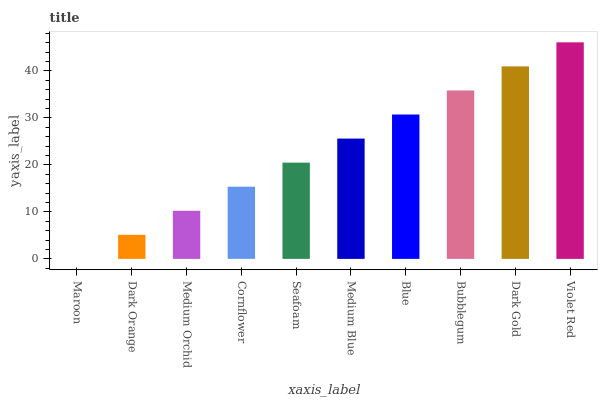Is Dark Orange the minimum?
Answer yes or no. No. Is Dark Orange the maximum?
Answer yes or no. No. Is Dark Orange greater than Maroon?
Answer yes or no. Yes. Is Maroon less than Dark Orange?
Answer yes or no. Yes. Is Maroon greater than Dark Orange?
Answer yes or no. No. Is Dark Orange less than Maroon?
Answer yes or no. No. Is Medium Blue the high median?
Answer yes or no. Yes. Is Seafoam the low median?
Answer yes or no. Yes. Is Dark Gold the high median?
Answer yes or no. No. Is Dark Gold the low median?
Answer yes or no. No. 